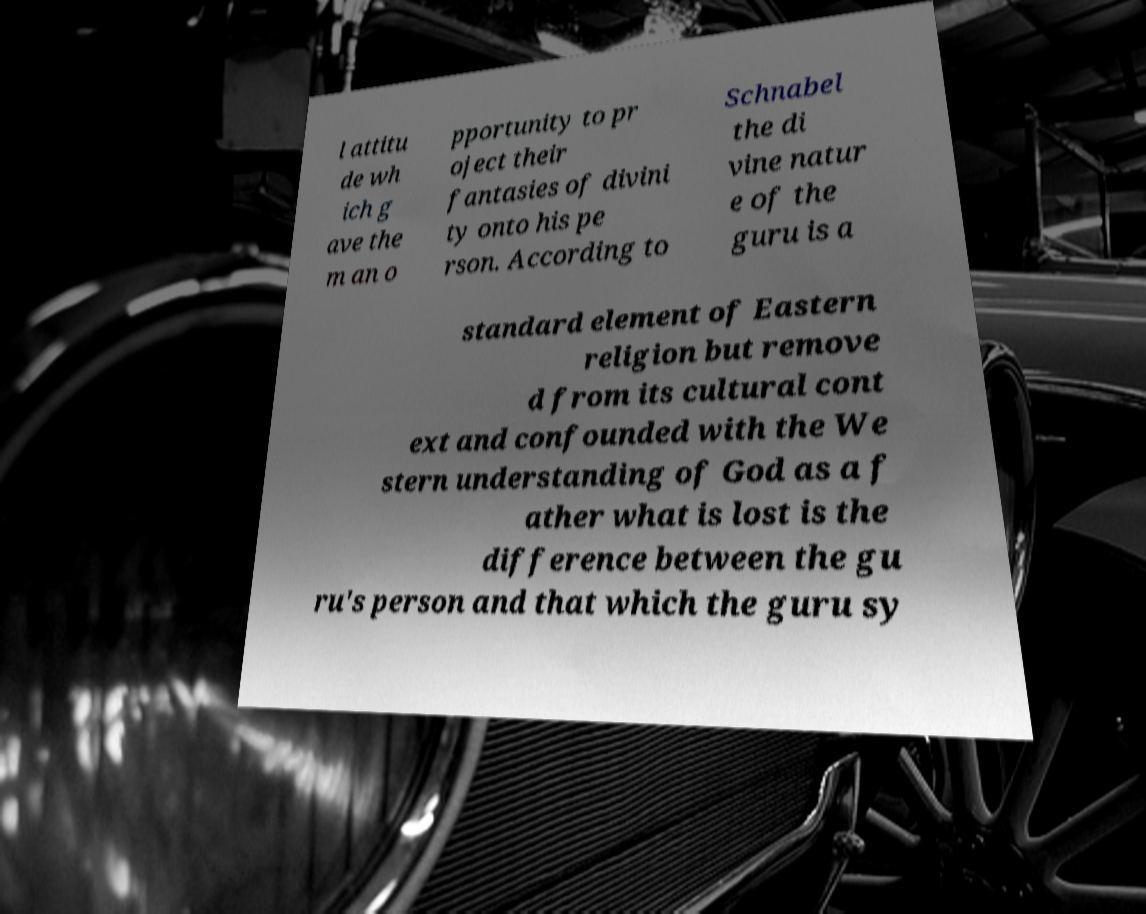What messages or text are displayed in this image? I need them in a readable, typed format. l attitu de wh ich g ave the m an o pportunity to pr oject their fantasies of divini ty onto his pe rson. According to Schnabel the di vine natur e of the guru is a standard element of Eastern religion but remove d from its cultural cont ext and confounded with the We stern understanding of God as a f ather what is lost is the difference between the gu ru's person and that which the guru sy 